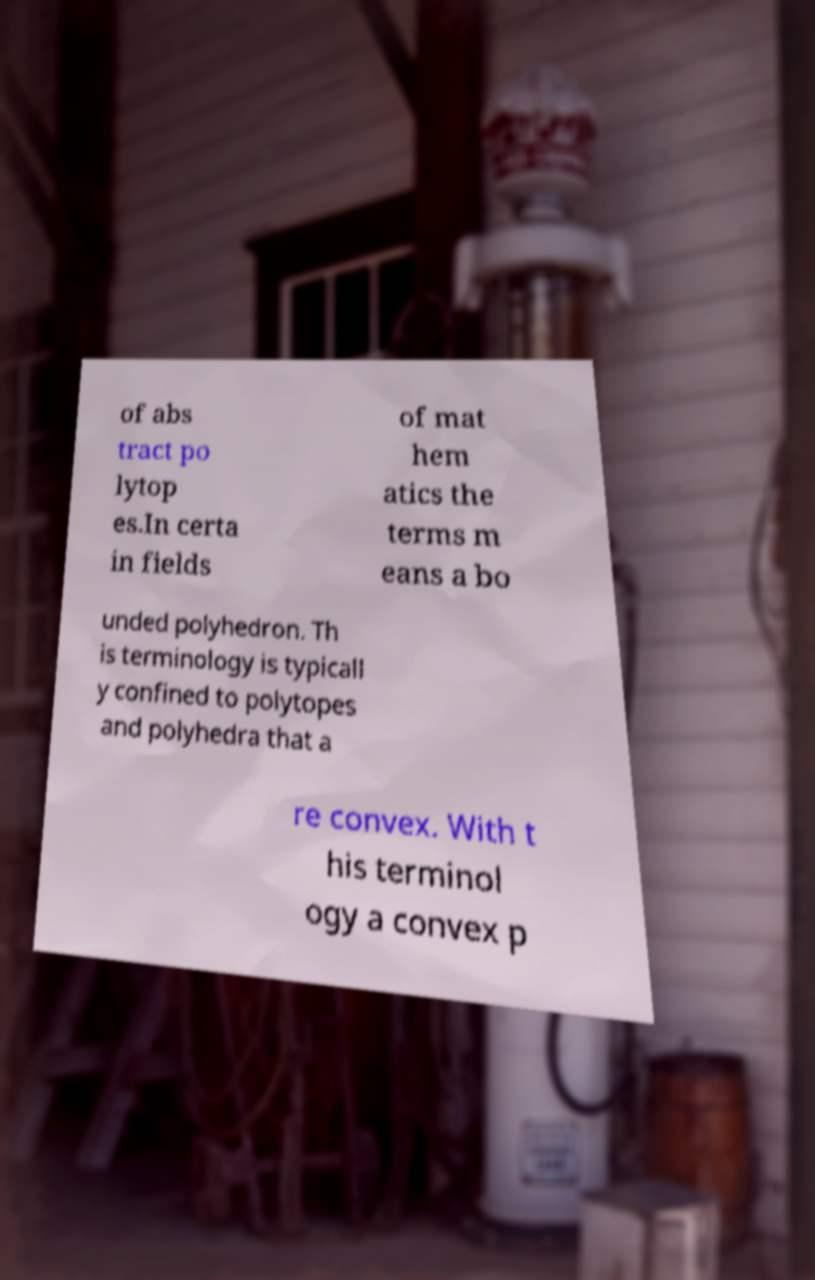I need the written content from this picture converted into text. Can you do that? of abs tract po lytop es.In certa in fields of mat hem atics the terms m eans a bo unded polyhedron. Th is terminology is typicall y confined to polytopes and polyhedra that a re convex. With t his terminol ogy a convex p 